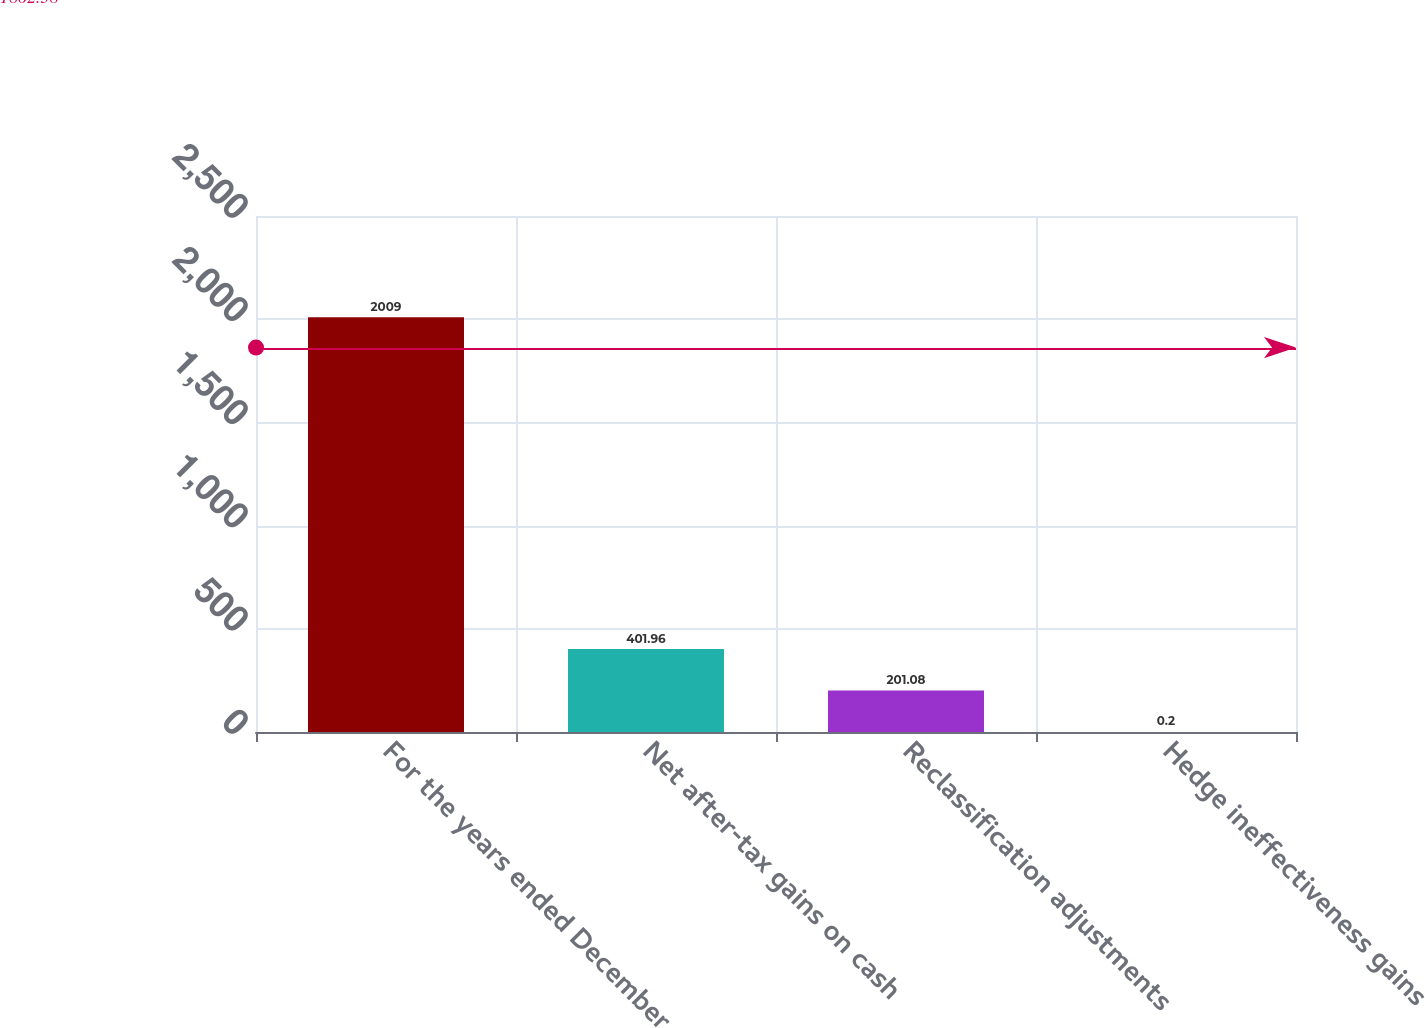<chart> <loc_0><loc_0><loc_500><loc_500><bar_chart><fcel>For the years ended December<fcel>Net after-tax gains on cash<fcel>Reclassification adjustments<fcel>Hedge ineffectiveness gains<nl><fcel>2009<fcel>401.96<fcel>201.08<fcel>0.2<nl></chart> 